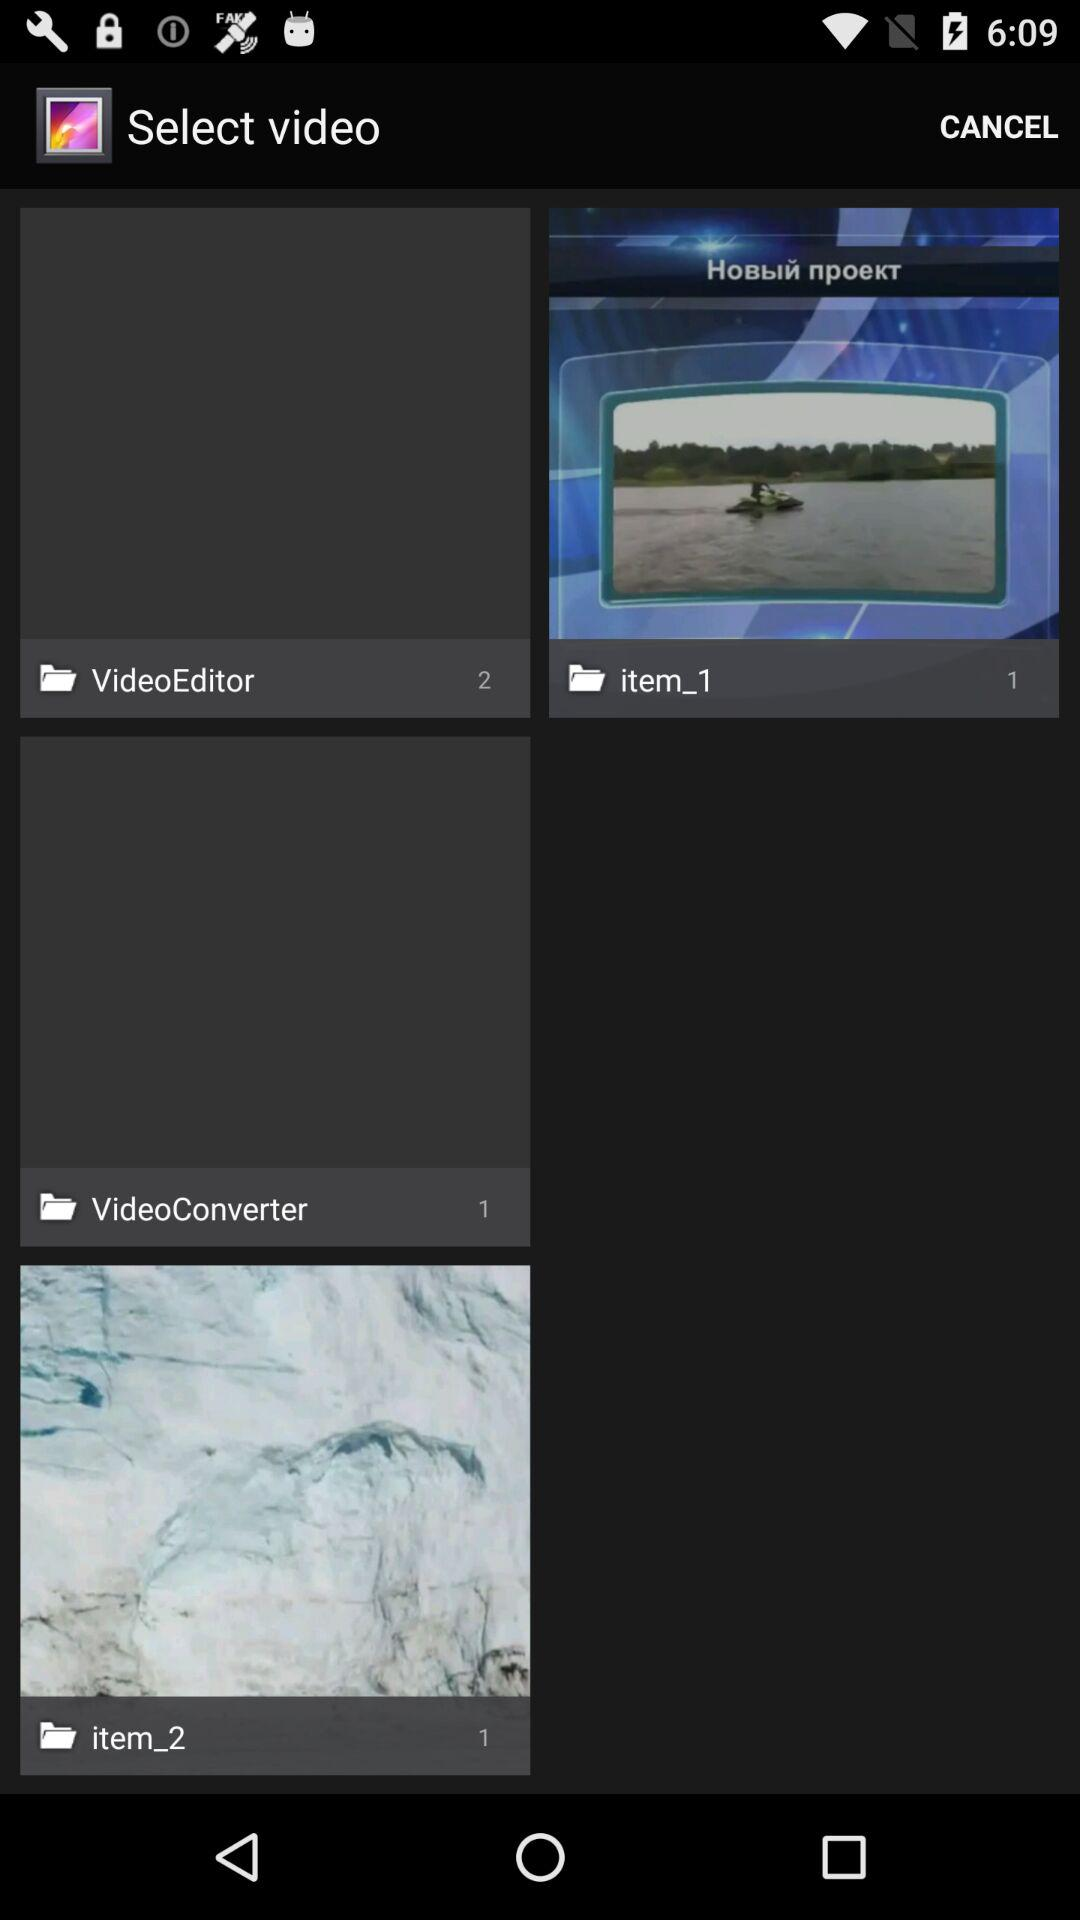How many images are there in the "VideoEditor" album? There are 2 images in the "VideoEditor" album. 